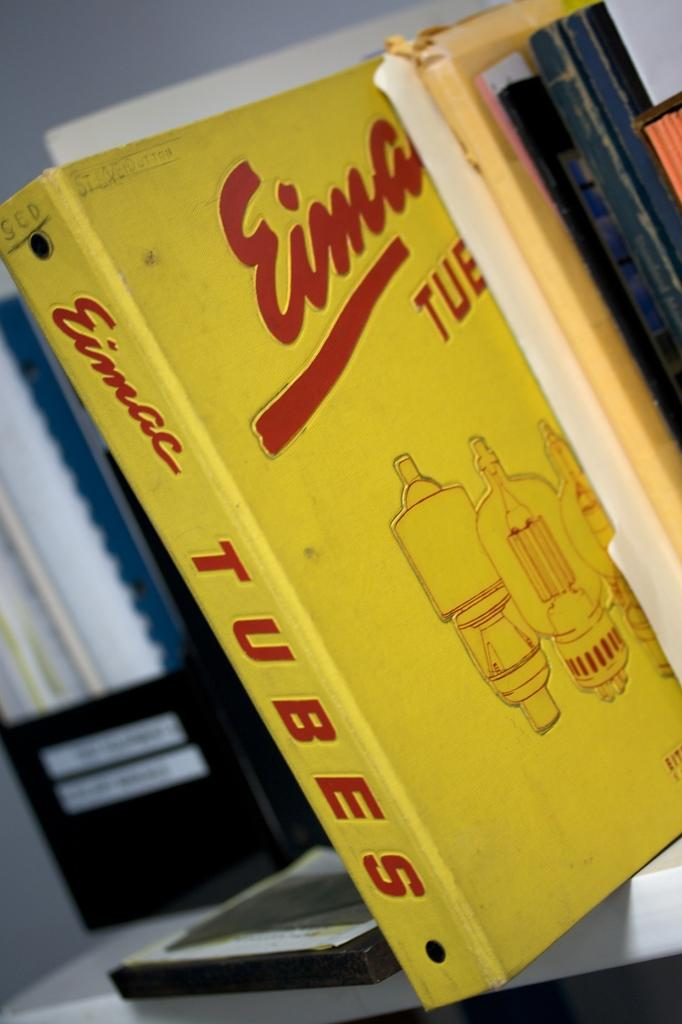Provide a one-sentence caption for the provided image. book spike placed on the bookshelf called tubes. 